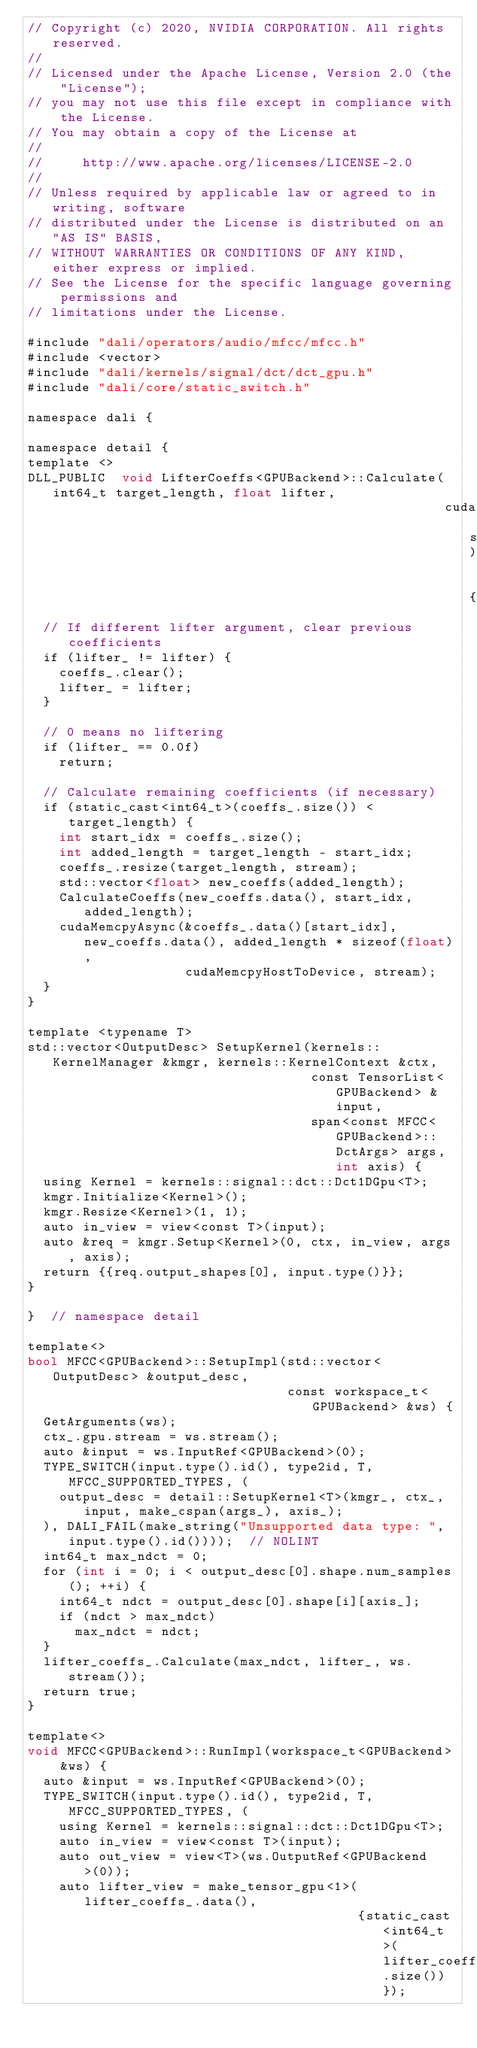<code> <loc_0><loc_0><loc_500><loc_500><_Cuda_>// Copyright (c) 2020, NVIDIA CORPORATION. All rights reserved.
//
// Licensed under the Apache License, Version 2.0 (the "License");
// you may not use this file except in compliance with the License.
// You may obtain a copy of the License at
//
//     http://www.apache.org/licenses/LICENSE-2.0
//
// Unless required by applicable law or agreed to in writing, software
// distributed under the License is distributed on an "AS IS" BASIS,
// WITHOUT WARRANTIES OR CONDITIONS OF ANY KIND, either express or implied.
// See the License for the specific language governing permissions and
// limitations under the License.

#include "dali/operators/audio/mfcc/mfcc.h"
#include <vector>
#include "dali/kernels/signal/dct/dct_gpu.h"
#include "dali/core/static_switch.h"

namespace dali {

namespace detail {
template <>
DLL_PUBLIC  void LifterCoeffs<GPUBackend>::Calculate(int64_t target_length, float lifter,
                                                     cudaStream_t stream)  {
  // If different lifter argument, clear previous coefficients
  if (lifter_ != lifter) {
    coeffs_.clear();
    lifter_ = lifter;
  }

  // 0 means no liftering
  if (lifter_ == 0.0f)
    return;

  // Calculate remaining coefficients (if necessary)
  if (static_cast<int64_t>(coeffs_.size()) < target_length) {
    int start_idx = coeffs_.size();
    int added_length = target_length - start_idx;
    coeffs_.resize(target_length, stream);
    std::vector<float> new_coeffs(added_length);
    CalculateCoeffs(new_coeffs.data(), start_idx, added_length);
    cudaMemcpyAsync(&coeffs_.data()[start_idx], new_coeffs.data(), added_length * sizeof(float),
                    cudaMemcpyHostToDevice, stream);
  }
}

template <typename T>
std::vector<OutputDesc> SetupKernel(kernels::KernelManager &kmgr, kernels::KernelContext &ctx,
                                    const TensorList<GPUBackend> &input,
                                    span<const MFCC<GPUBackend>::DctArgs> args, int axis) {
  using Kernel = kernels::signal::dct::Dct1DGpu<T>;
  kmgr.Initialize<Kernel>();
  kmgr.Resize<Kernel>(1, 1);
  auto in_view = view<const T>(input);
  auto &req = kmgr.Setup<Kernel>(0, ctx, in_view, args, axis);
  return {{req.output_shapes[0], input.type()}};
}

}  // namespace detail

template<>
bool MFCC<GPUBackend>::SetupImpl(std::vector<OutputDesc> &output_desc,
                                 const workspace_t<GPUBackend> &ws) {
  GetArguments(ws);
  ctx_.gpu.stream = ws.stream();
  auto &input = ws.InputRef<GPUBackend>(0);
  TYPE_SWITCH(input.type().id(), type2id, T, MFCC_SUPPORTED_TYPES, (
    output_desc = detail::SetupKernel<T>(kmgr_, ctx_, input, make_cspan(args_), axis_);
  ), DALI_FAIL(make_string("Unsupported data type: ", input.type().id())));  // NOLINT
  int64_t max_ndct = 0;
  for (int i = 0; i < output_desc[0].shape.num_samples(); ++i) {
    int64_t ndct = output_desc[0].shape[i][axis_];
    if (ndct > max_ndct)
      max_ndct = ndct;
  }
  lifter_coeffs_.Calculate(max_ndct, lifter_, ws.stream());
  return true;
}

template<>
void MFCC<GPUBackend>::RunImpl(workspace_t<GPUBackend> &ws) {
  auto &input = ws.InputRef<GPUBackend>(0);
  TYPE_SWITCH(input.type().id(), type2id, T, MFCC_SUPPORTED_TYPES, (
    using Kernel = kernels::signal::dct::Dct1DGpu<T>;
    auto in_view = view<const T>(input);
    auto out_view = view<T>(ws.OutputRef<GPUBackend>(0));
    auto lifter_view = make_tensor_gpu<1>(lifter_coeffs_.data(),
                                          {static_cast<int64_t>(lifter_coeffs_.size())});</code> 